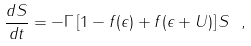<formula> <loc_0><loc_0><loc_500><loc_500>\frac { d S } { d t } = - \Gamma \left [ 1 - f ( \epsilon ) + f ( \epsilon + U ) \right ] S \ ,</formula> 